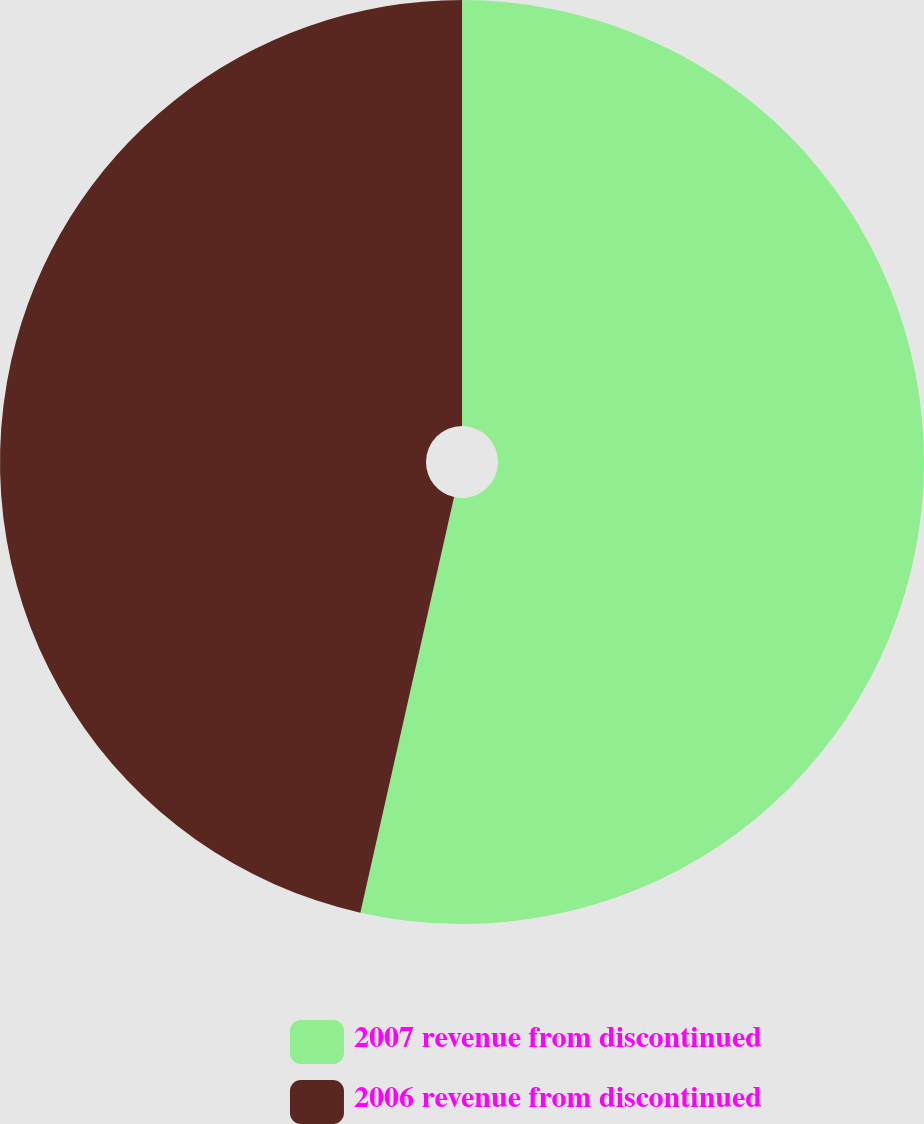Convert chart to OTSL. <chart><loc_0><loc_0><loc_500><loc_500><pie_chart><fcel>2007 revenue from discontinued<fcel>2006 revenue from discontinued<nl><fcel>53.53%<fcel>46.47%<nl></chart> 